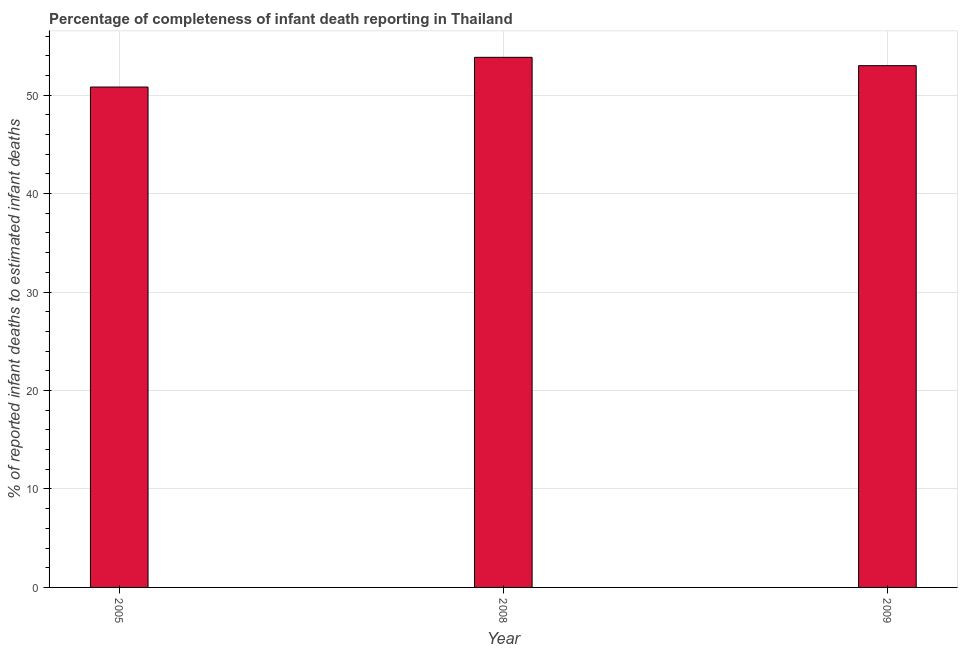What is the title of the graph?
Provide a short and direct response. Percentage of completeness of infant death reporting in Thailand. What is the label or title of the X-axis?
Offer a terse response. Year. What is the label or title of the Y-axis?
Give a very brief answer. % of reported infant deaths to estimated infant deaths. What is the completeness of infant death reporting in 2005?
Provide a succinct answer. 50.82. Across all years, what is the maximum completeness of infant death reporting?
Offer a very short reply. 53.83. Across all years, what is the minimum completeness of infant death reporting?
Your answer should be very brief. 50.82. In which year was the completeness of infant death reporting minimum?
Keep it short and to the point. 2005. What is the sum of the completeness of infant death reporting?
Make the answer very short. 157.64. What is the difference between the completeness of infant death reporting in 2005 and 2008?
Give a very brief answer. -3.02. What is the average completeness of infant death reporting per year?
Ensure brevity in your answer.  52.55. What is the median completeness of infant death reporting?
Your answer should be very brief. 52.99. Do a majority of the years between 2009 and 2005 (inclusive) have completeness of infant death reporting greater than 22 %?
Provide a short and direct response. Yes. What is the ratio of the completeness of infant death reporting in 2008 to that in 2009?
Your response must be concise. 1.02. Is the completeness of infant death reporting in 2008 less than that in 2009?
Ensure brevity in your answer.  No. Is the difference between the completeness of infant death reporting in 2005 and 2008 greater than the difference between any two years?
Offer a very short reply. Yes. What is the difference between the highest and the second highest completeness of infant death reporting?
Offer a terse response. 0.85. What is the difference between the highest and the lowest completeness of infant death reporting?
Provide a short and direct response. 3.02. In how many years, is the completeness of infant death reporting greater than the average completeness of infant death reporting taken over all years?
Ensure brevity in your answer.  2. How many bars are there?
Keep it short and to the point. 3. Are all the bars in the graph horizontal?
Offer a very short reply. No. Are the values on the major ticks of Y-axis written in scientific E-notation?
Your response must be concise. No. What is the % of reported infant deaths to estimated infant deaths of 2005?
Offer a terse response. 50.82. What is the % of reported infant deaths to estimated infant deaths of 2008?
Give a very brief answer. 53.83. What is the % of reported infant deaths to estimated infant deaths in 2009?
Offer a very short reply. 52.99. What is the difference between the % of reported infant deaths to estimated infant deaths in 2005 and 2008?
Provide a short and direct response. -3.02. What is the difference between the % of reported infant deaths to estimated infant deaths in 2005 and 2009?
Your answer should be very brief. -2.17. What is the difference between the % of reported infant deaths to estimated infant deaths in 2008 and 2009?
Offer a very short reply. 0.85. What is the ratio of the % of reported infant deaths to estimated infant deaths in 2005 to that in 2008?
Offer a very short reply. 0.94. 